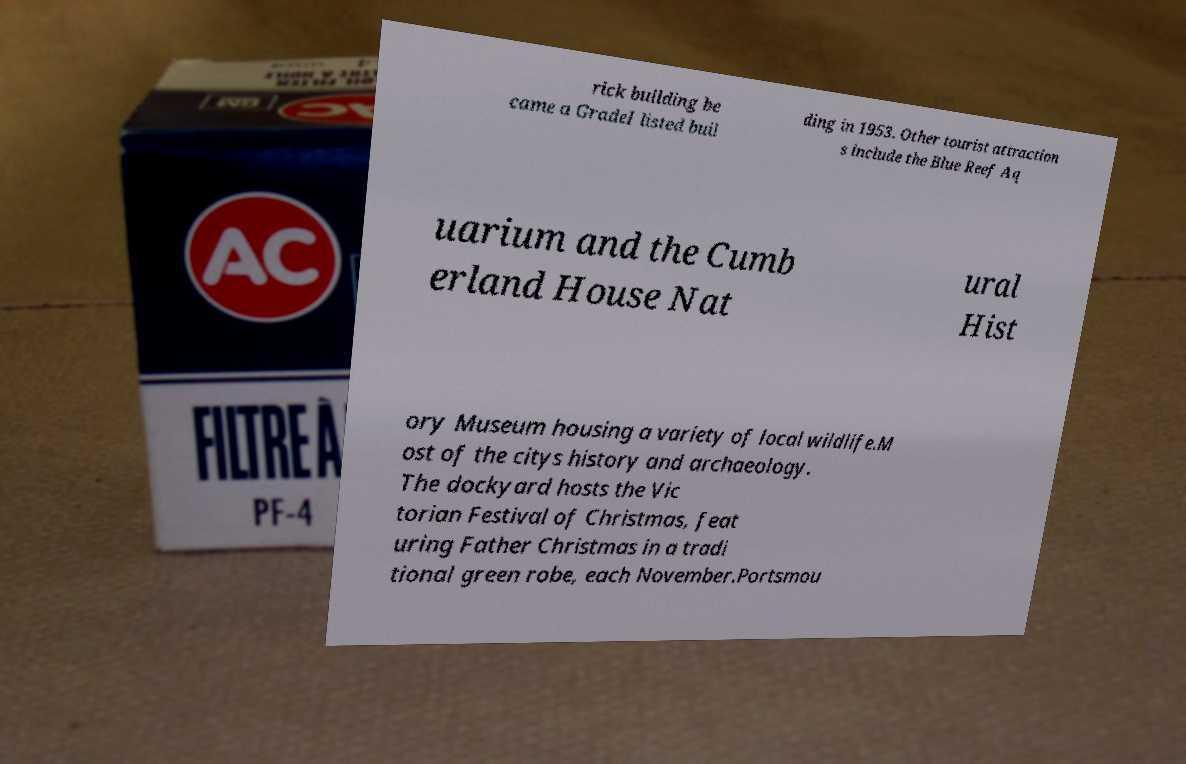Could you assist in decoding the text presented in this image and type it out clearly? rick building be came a GradeI listed buil ding in 1953. Other tourist attraction s include the Blue Reef Aq uarium and the Cumb erland House Nat ural Hist ory Museum housing a variety of local wildlife.M ost of the citys history and archaeology. The dockyard hosts the Vic torian Festival of Christmas, feat uring Father Christmas in a tradi tional green robe, each November.Portsmou 